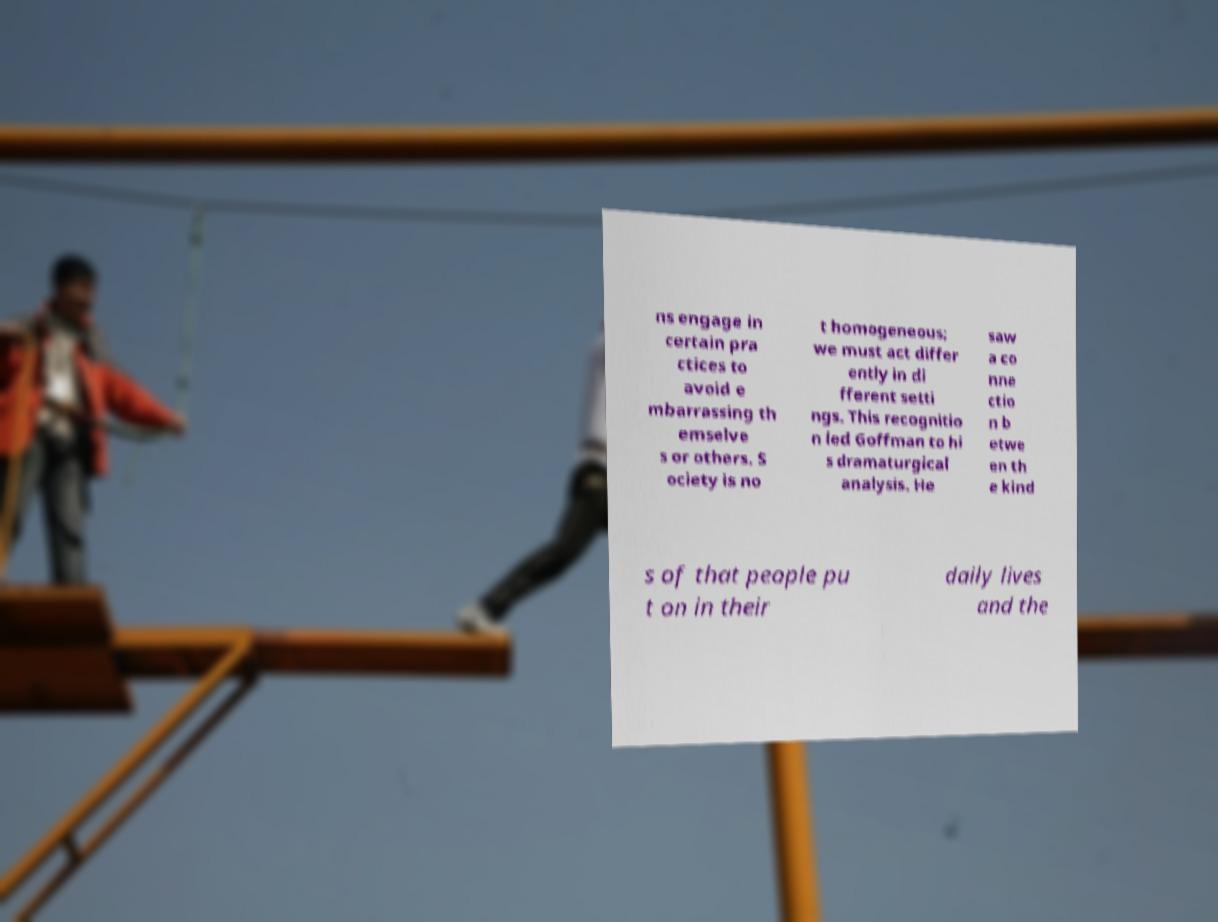For documentation purposes, I need the text within this image transcribed. Could you provide that? ns engage in certain pra ctices to avoid e mbarrassing th emselve s or others. S ociety is no t homogeneous; we must act differ ently in di fferent setti ngs. This recognitio n led Goffman to hi s dramaturgical analysis. He saw a co nne ctio n b etwe en th e kind s of that people pu t on in their daily lives and the 